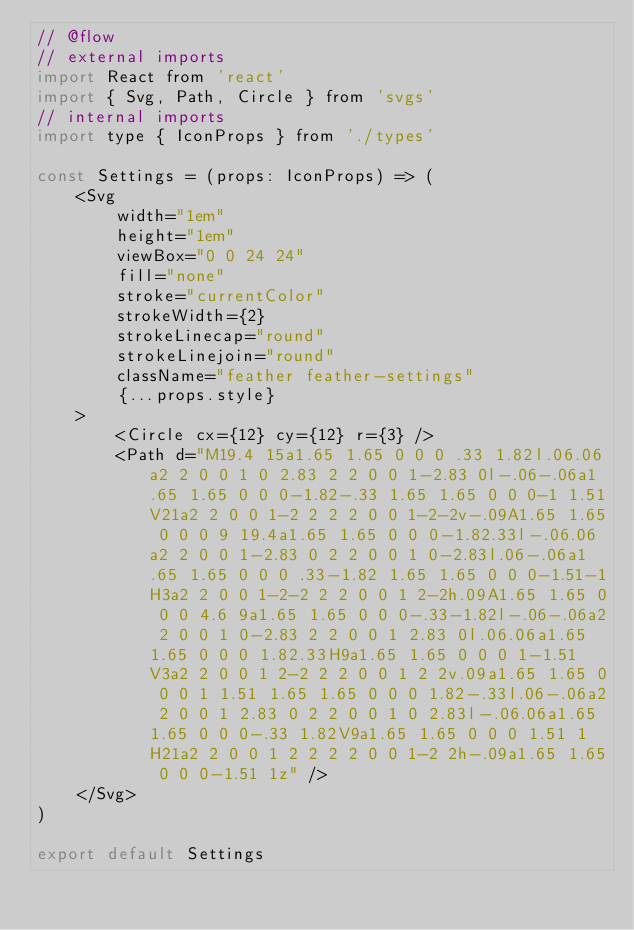<code> <loc_0><loc_0><loc_500><loc_500><_JavaScript_>// @flow
// external imports
import React from 'react'
import { Svg, Path, Circle } from 'svgs'
// internal imports
import type { IconProps } from './types'

const Settings = (props: IconProps) => (
    <Svg
        width="1em"
        height="1em"
        viewBox="0 0 24 24"
        fill="none"
        stroke="currentColor"
        strokeWidth={2}
        strokeLinecap="round"
        strokeLinejoin="round"
        className="feather feather-settings"
        {...props.style}
    >
        <Circle cx={12} cy={12} r={3} />
        <Path d="M19.4 15a1.65 1.65 0 0 0 .33 1.82l.06.06a2 2 0 0 1 0 2.83 2 2 0 0 1-2.83 0l-.06-.06a1.65 1.65 0 0 0-1.82-.33 1.65 1.65 0 0 0-1 1.51V21a2 2 0 0 1-2 2 2 2 0 0 1-2-2v-.09A1.65 1.65 0 0 0 9 19.4a1.65 1.65 0 0 0-1.82.33l-.06.06a2 2 0 0 1-2.83 0 2 2 0 0 1 0-2.83l.06-.06a1.65 1.65 0 0 0 .33-1.82 1.65 1.65 0 0 0-1.51-1H3a2 2 0 0 1-2-2 2 2 0 0 1 2-2h.09A1.65 1.65 0 0 0 4.6 9a1.65 1.65 0 0 0-.33-1.82l-.06-.06a2 2 0 0 1 0-2.83 2 2 0 0 1 2.83 0l.06.06a1.65 1.65 0 0 0 1.82.33H9a1.65 1.65 0 0 0 1-1.51V3a2 2 0 0 1 2-2 2 2 0 0 1 2 2v.09a1.65 1.65 0 0 0 1 1.51 1.65 1.65 0 0 0 1.82-.33l.06-.06a2 2 0 0 1 2.83 0 2 2 0 0 1 0 2.83l-.06.06a1.65 1.65 0 0 0-.33 1.82V9a1.65 1.65 0 0 0 1.51 1H21a2 2 0 0 1 2 2 2 2 0 0 1-2 2h-.09a1.65 1.65 0 0 0-1.51 1z" />
    </Svg>
)

export default Settings
</code> 